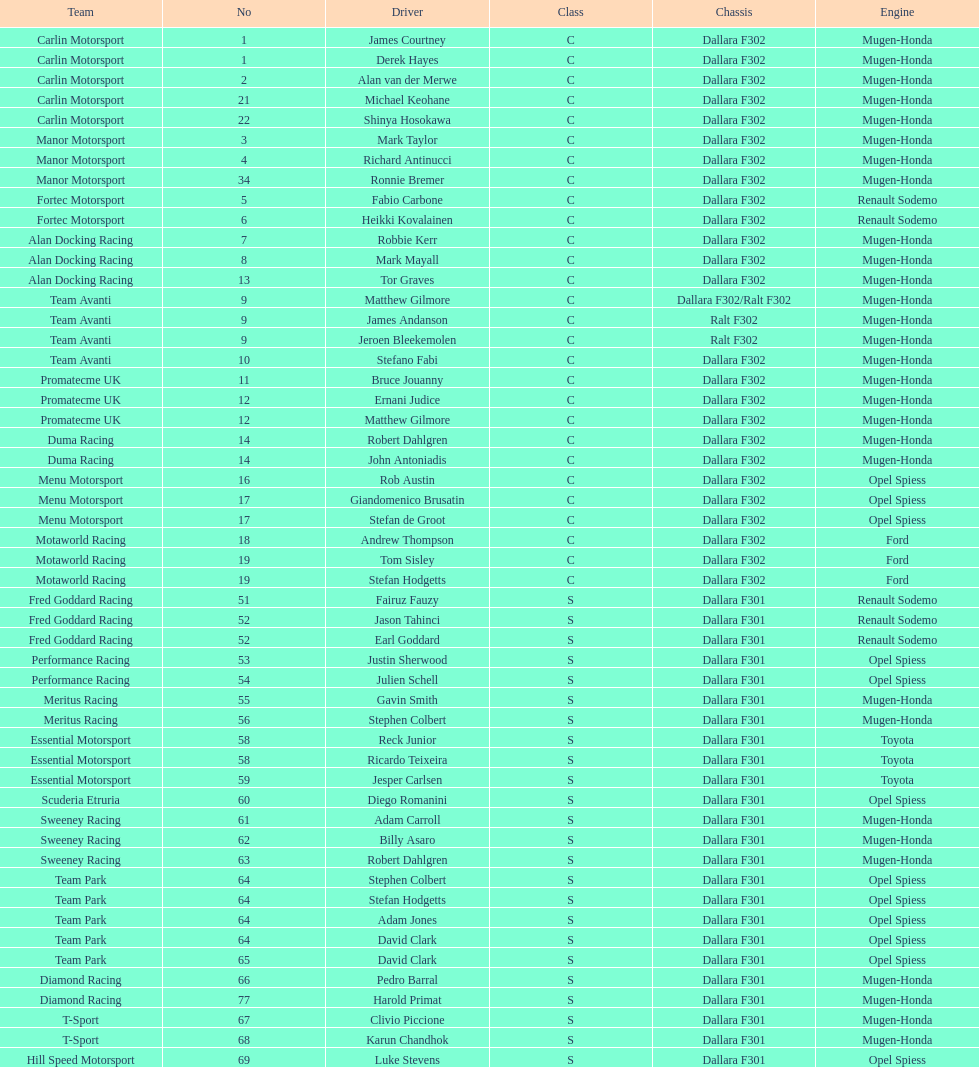Besides clivio piccione, who is the other driver on the t-sport team? Karun Chandhok. 